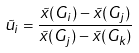Convert formula to latex. <formula><loc_0><loc_0><loc_500><loc_500>\tilde { u } _ { i } = \frac { \tilde { x } ( G _ { i } ) - \tilde { x } ( G _ { j } ) } { \tilde { x } ( G _ { j } ) - \tilde { x } ( G _ { k } ) }</formula> 